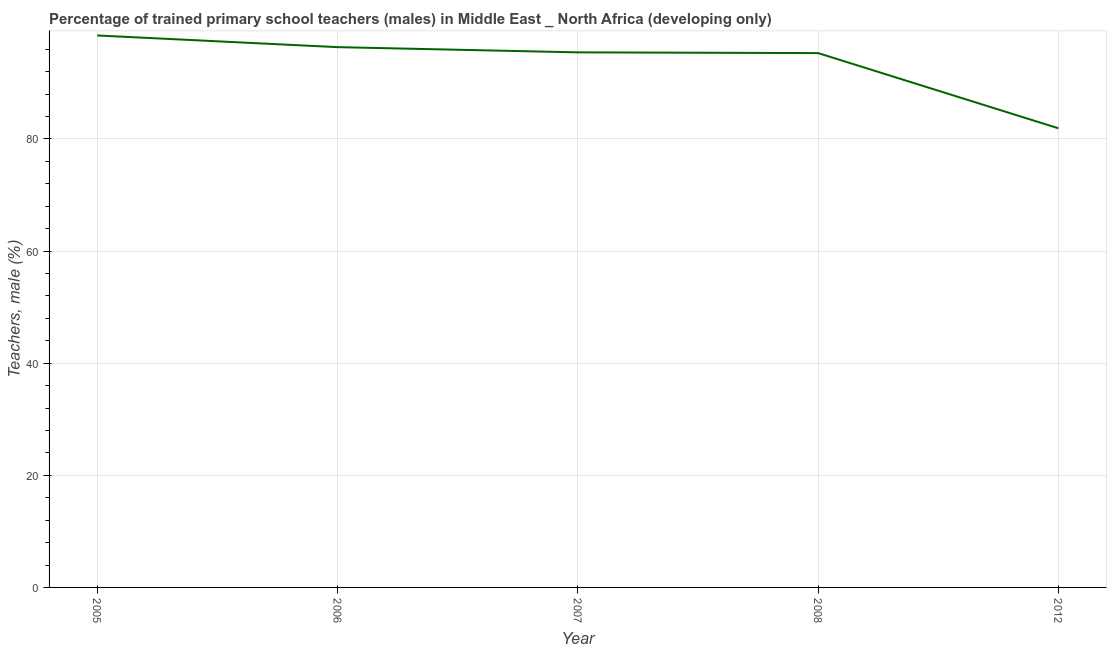What is the percentage of trained male teachers in 2005?
Make the answer very short. 98.46. Across all years, what is the maximum percentage of trained male teachers?
Provide a short and direct response. 98.46. Across all years, what is the minimum percentage of trained male teachers?
Your response must be concise. 81.9. In which year was the percentage of trained male teachers maximum?
Offer a terse response. 2005. What is the sum of the percentage of trained male teachers?
Keep it short and to the point. 467.5. What is the difference between the percentage of trained male teachers in 2006 and 2012?
Your answer should be very brief. 14.48. What is the average percentage of trained male teachers per year?
Make the answer very short. 93.5. What is the median percentage of trained male teachers?
Ensure brevity in your answer.  95.45. In how many years, is the percentage of trained male teachers greater than 40 %?
Make the answer very short. 5. Do a majority of the years between 2012 and 2007 (inclusive) have percentage of trained male teachers greater than 92 %?
Make the answer very short. No. What is the ratio of the percentage of trained male teachers in 2008 to that in 2012?
Give a very brief answer. 1.16. Is the percentage of trained male teachers in 2008 less than that in 2012?
Make the answer very short. No. What is the difference between the highest and the second highest percentage of trained male teachers?
Ensure brevity in your answer.  2.08. Is the sum of the percentage of trained male teachers in 2005 and 2008 greater than the maximum percentage of trained male teachers across all years?
Offer a terse response. Yes. What is the difference between the highest and the lowest percentage of trained male teachers?
Provide a short and direct response. 16.56. In how many years, is the percentage of trained male teachers greater than the average percentage of trained male teachers taken over all years?
Your response must be concise. 4. How many years are there in the graph?
Offer a terse response. 5. Are the values on the major ticks of Y-axis written in scientific E-notation?
Give a very brief answer. No. Does the graph contain grids?
Give a very brief answer. Yes. What is the title of the graph?
Offer a terse response. Percentage of trained primary school teachers (males) in Middle East _ North Africa (developing only). What is the label or title of the Y-axis?
Your answer should be very brief. Teachers, male (%). What is the Teachers, male (%) in 2005?
Ensure brevity in your answer.  98.46. What is the Teachers, male (%) in 2006?
Offer a terse response. 96.38. What is the Teachers, male (%) of 2007?
Your answer should be very brief. 95.45. What is the Teachers, male (%) in 2008?
Offer a terse response. 95.32. What is the Teachers, male (%) in 2012?
Your answer should be compact. 81.9. What is the difference between the Teachers, male (%) in 2005 and 2006?
Ensure brevity in your answer.  2.08. What is the difference between the Teachers, male (%) in 2005 and 2007?
Offer a very short reply. 3.01. What is the difference between the Teachers, male (%) in 2005 and 2008?
Your answer should be compact. 3.14. What is the difference between the Teachers, male (%) in 2005 and 2012?
Your answer should be very brief. 16.56. What is the difference between the Teachers, male (%) in 2006 and 2007?
Your answer should be very brief. 0.93. What is the difference between the Teachers, male (%) in 2006 and 2008?
Offer a very short reply. 1.06. What is the difference between the Teachers, male (%) in 2006 and 2012?
Provide a short and direct response. 14.48. What is the difference between the Teachers, male (%) in 2007 and 2008?
Your answer should be very brief. 0.13. What is the difference between the Teachers, male (%) in 2007 and 2012?
Keep it short and to the point. 13.55. What is the difference between the Teachers, male (%) in 2008 and 2012?
Offer a terse response. 13.42. What is the ratio of the Teachers, male (%) in 2005 to that in 2006?
Give a very brief answer. 1.02. What is the ratio of the Teachers, male (%) in 2005 to that in 2007?
Make the answer very short. 1.03. What is the ratio of the Teachers, male (%) in 2005 to that in 2008?
Your response must be concise. 1.03. What is the ratio of the Teachers, male (%) in 2005 to that in 2012?
Offer a terse response. 1.2. What is the ratio of the Teachers, male (%) in 2006 to that in 2007?
Make the answer very short. 1.01. What is the ratio of the Teachers, male (%) in 2006 to that in 2008?
Ensure brevity in your answer.  1.01. What is the ratio of the Teachers, male (%) in 2006 to that in 2012?
Your answer should be very brief. 1.18. What is the ratio of the Teachers, male (%) in 2007 to that in 2012?
Ensure brevity in your answer.  1.17. What is the ratio of the Teachers, male (%) in 2008 to that in 2012?
Make the answer very short. 1.16. 